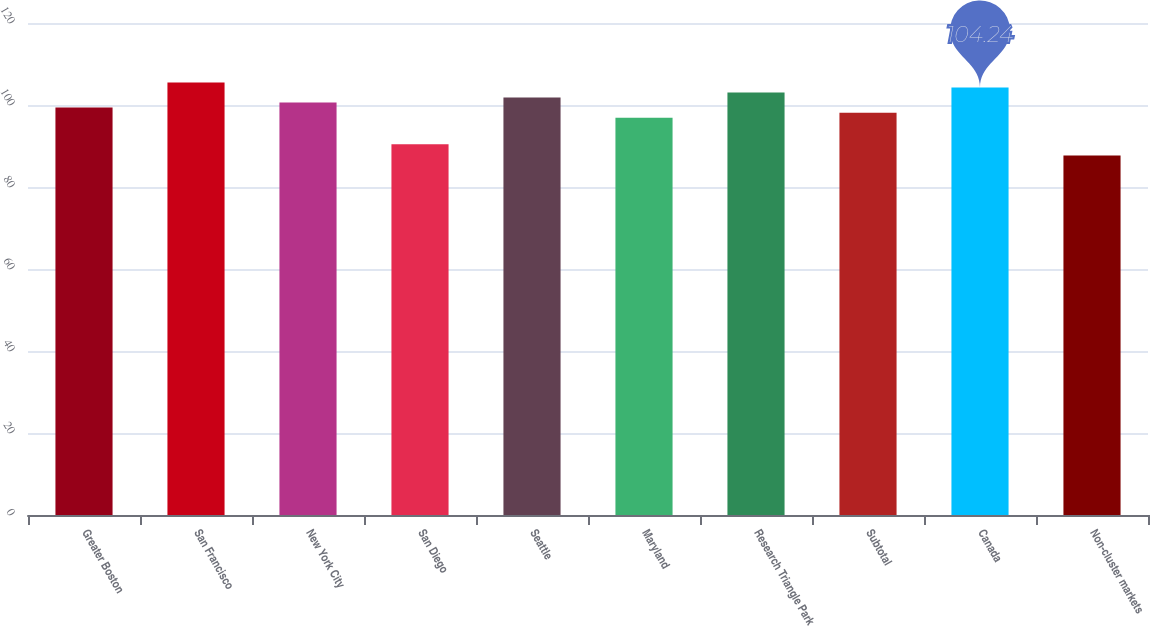Convert chart to OTSL. <chart><loc_0><loc_0><loc_500><loc_500><bar_chart><fcel>Greater Boston<fcel>San Francisco<fcel>New York City<fcel>San Diego<fcel>Seattle<fcel>Maryland<fcel>Research Triangle Park<fcel>Subtotal<fcel>Canada<fcel>Non-cluster markets<nl><fcel>99.36<fcel>105.46<fcel>100.58<fcel>90.4<fcel>101.8<fcel>96.92<fcel>103.02<fcel>98.14<fcel>104.24<fcel>87.7<nl></chart> 